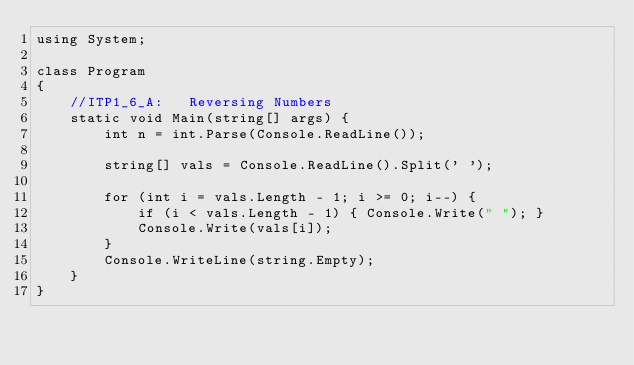<code> <loc_0><loc_0><loc_500><loc_500><_C#_>using System;

class Program
{
    //ITP1_6_A:   Reversing Numbers
    static void Main(string[] args) {
        int n = int.Parse(Console.ReadLine());

        string[] vals = Console.ReadLine().Split(' ');

        for (int i = vals.Length - 1; i >= 0; i--) {
            if (i < vals.Length - 1) { Console.Write(" "); }
            Console.Write(vals[i]);
        }
        Console.WriteLine(string.Empty);
    }
}

</code> 